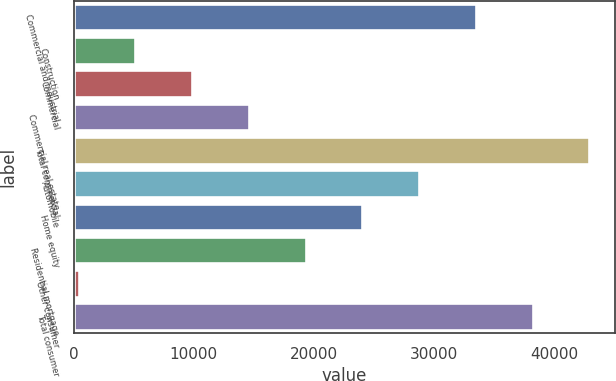Convert chart to OTSL. <chart><loc_0><loc_0><loc_500><loc_500><bar_chart><fcel>Commercial and industrial<fcel>Construction<fcel>Commercial<fcel>Commercial real estate<fcel>Total commercial<fcel>Automobile<fcel>Home equity<fcel>Residential mortgage<fcel>Other consumer<fcel>Total consumer<nl><fcel>33483.4<fcel>5138.2<fcel>9862.4<fcel>14586.6<fcel>42931.8<fcel>28759.2<fcel>24035<fcel>19310.8<fcel>414<fcel>38207.6<nl></chart> 